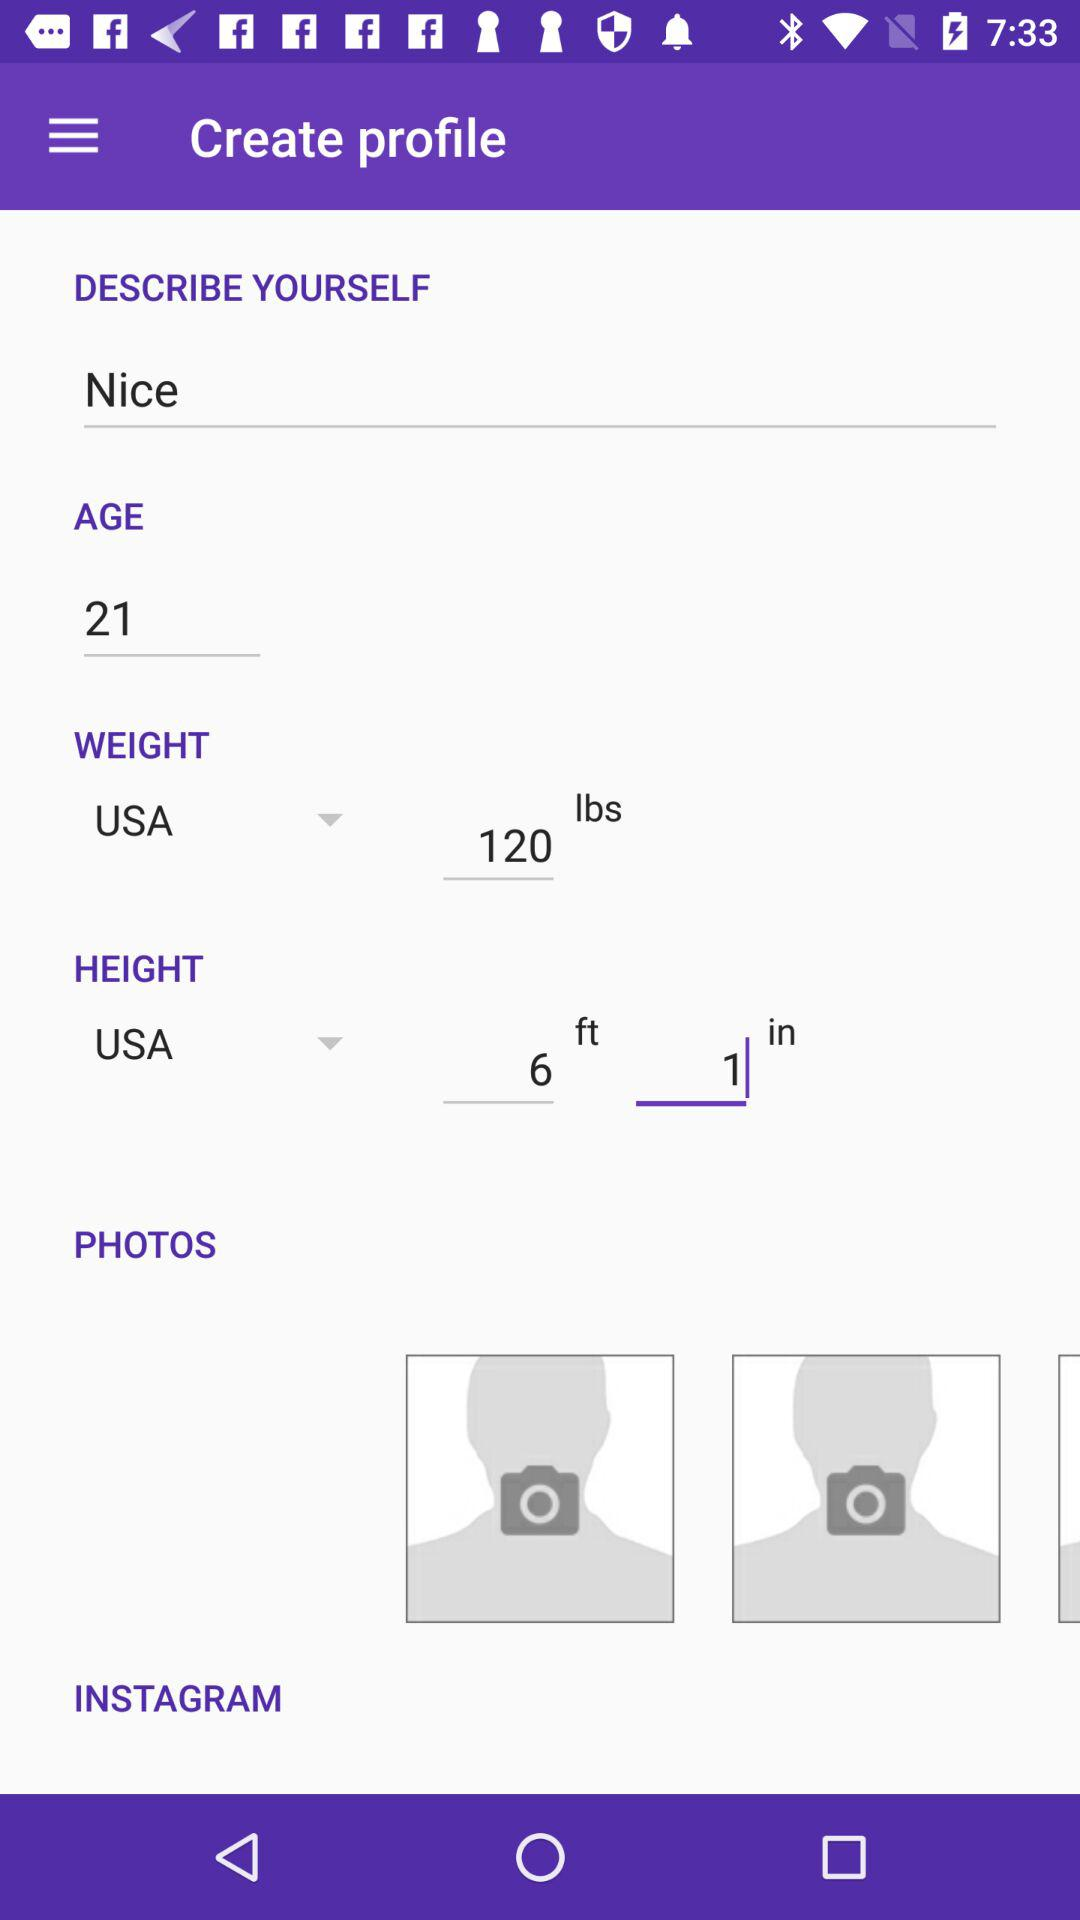What's the opted country? The opted country is the USA. 